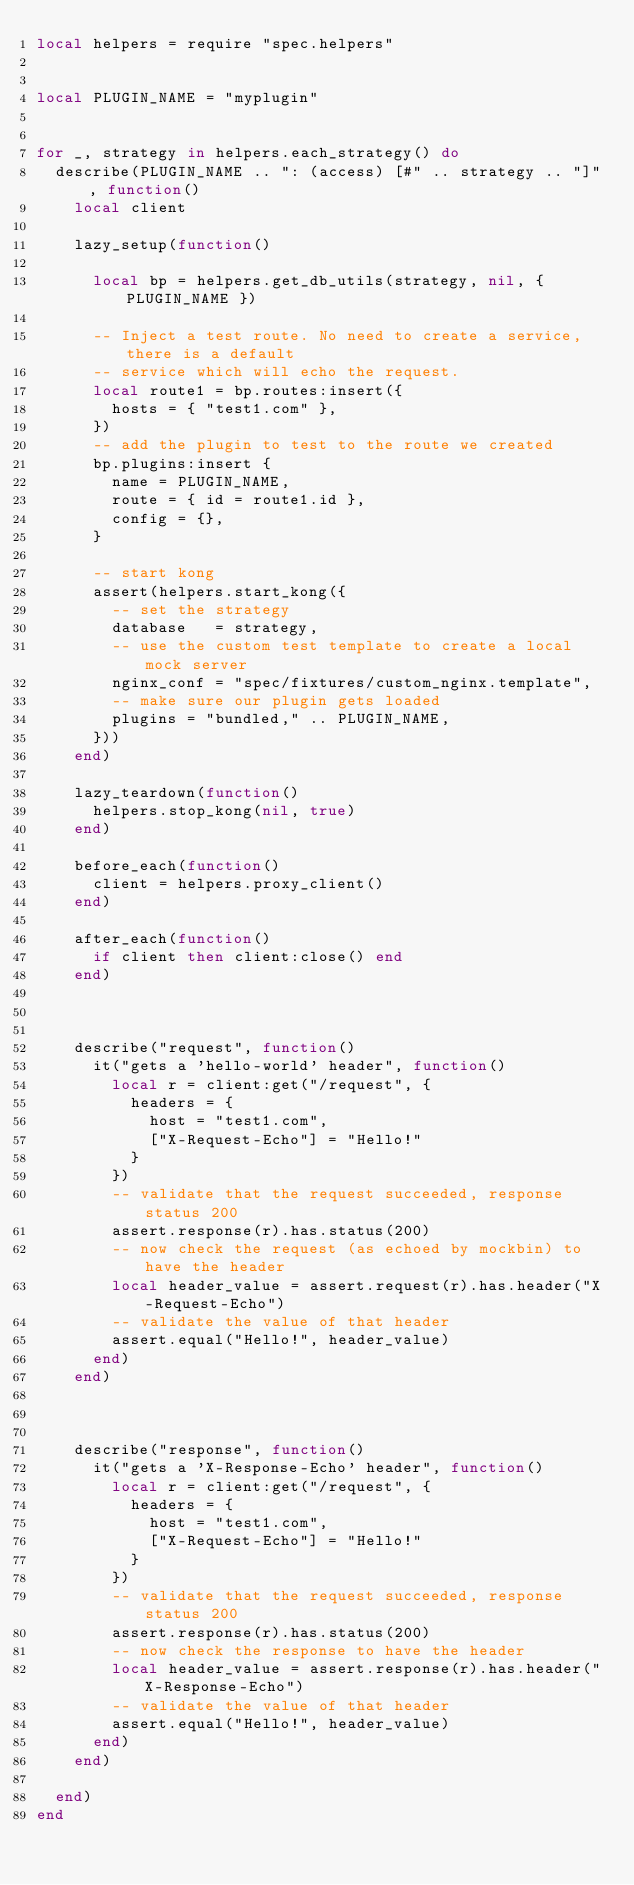Convert code to text. <code><loc_0><loc_0><loc_500><loc_500><_Lua_>local helpers = require "spec.helpers"


local PLUGIN_NAME = "myplugin"


for _, strategy in helpers.each_strategy() do
  describe(PLUGIN_NAME .. ": (access) [#" .. strategy .. "]", function()
    local client

    lazy_setup(function()

      local bp = helpers.get_db_utils(strategy, nil, { PLUGIN_NAME })

      -- Inject a test route. No need to create a service, there is a default
      -- service which will echo the request.
      local route1 = bp.routes:insert({
        hosts = { "test1.com" },
      })
      -- add the plugin to test to the route we created
      bp.plugins:insert {
        name = PLUGIN_NAME,
        route = { id = route1.id },
        config = {},
      }

      -- start kong
      assert(helpers.start_kong({
        -- set the strategy
        database   = strategy,
        -- use the custom test template to create a local mock server
        nginx_conf = "spec/fixtures/custom_nginx.template",
        -- make sure our plugin gets loaded
        plugins = "bundled," .. PLUGIN_NAME,
      }))
    end)

    lazy_teardown(function()
      helpers.stop_kong(nil, true)
    end)

    before_each(function()
      client = helpers.proxy_client()
    end)

    after_each(function()
      if client then client:close() end
    end)



    describe("request", function()
      it("gets a 'hello-world' header", function()
        local r = client:get("/request", {
          headers = {
            host = "test1.com",
            ["X-Request-Echo"] = "Hello!"
          }
        })
        -- validate that the request succeeded, response status 200
        assert.response(r).has.status(200)
        -- now check the request (as echoed by mockbin) to have the header
        local header_value = assert.request(r).has.header("X-Request-Echo")
        -- validate the value of that header
        assert.equal("Hello!", header_value)
      end)
    end)



    describe("response", function()
      it("gets a 'X-Response-Echo' header", function()
        local r = client:get("/request", {
          headers = {
            host = "test1.com",
            ["X-Request-Echo"] = "Hello!"
          }
        })
        -- validate that the request succeeded, response status 200
        assert.response(r).has.status(200)
        -- now check the response to have the header
        local header_value = assert.response(r).has.header("X-Response-Echo")
        -- validate the value of that header
        assert.equal("Hello!", header_value)
      end)
    end)

  end)
end
</code> 